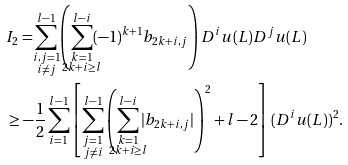<formula> <loc_0><loc_0><loc_500><loc_500>& I _ { 2 } = \sum _ { \mathclap { \substack { i , j = 1 \\ i \neq j } } } ^ { l - 1 } \left ( \sum _ { \mathclap { \substack { k = 1 \\ 2 k + i \geq l } } } ^ { l - i } ( - 1 ) ^ { k + 1 } b _ { 2 k + i , j } \right ) D ^ { i } u ( L ) D ^ { j } u ( L ) \\ & \geq - \frac { 1 } { 2 } \sum _ { i = 1 } ^ { l - 1 } \left [ \sum _ { \mathclap { \substack { j = 1 \\ j \neq i } } } ^ { l - 1 } \left ( \sum _ { \mathclap { \substack { k = 1 \\ 2 k + i \geq l } } } ^ { l - i } | b _ { 2 k + i , j } | \right ) ^ { 2 } + l - 2 \right ] ( D ^ { i } u ( L ) ) ^ { 2 } .</formula> 